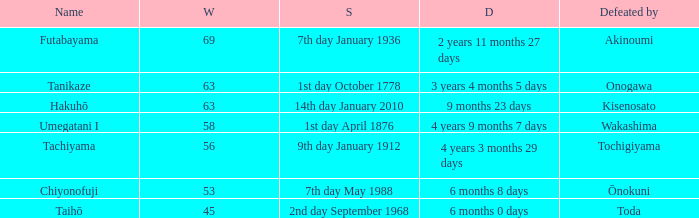What is the Duration for less than 53 consecutive wins? 6 months 0 days. Could you help me parse every detail presented in this table? {'header': ['Name', 'W', 'S', 'D', 'Defeated by'], 'rows': [['Futabayama', '69', '7th day January 1936', '2 years 11 months 27 days', 'Akinoumi'], ['Tanikaze', '63', '1st day October 1778', '3 years 4 months 5 days', 'Onogawa'], ['Hakuhō', '63', '14th day January 2010', '9 months 23 days', 'Kisenosato'], ['Umegatani I', '58', '1st day April 1876', '4 years 9 months 7 days', 'Wakashima'], ['Tachiyama', '56', '9th day January 1912', '4 years 3 months 29 days', 'Tochigiyama'], ['Chiyonofuji', '53', '7th day May 1988', '6 months 8 days', 'Ōnokuni'], ['Taihō', '45', '2nd day September 1968', '6 months 0 days', 'Toda']]} 